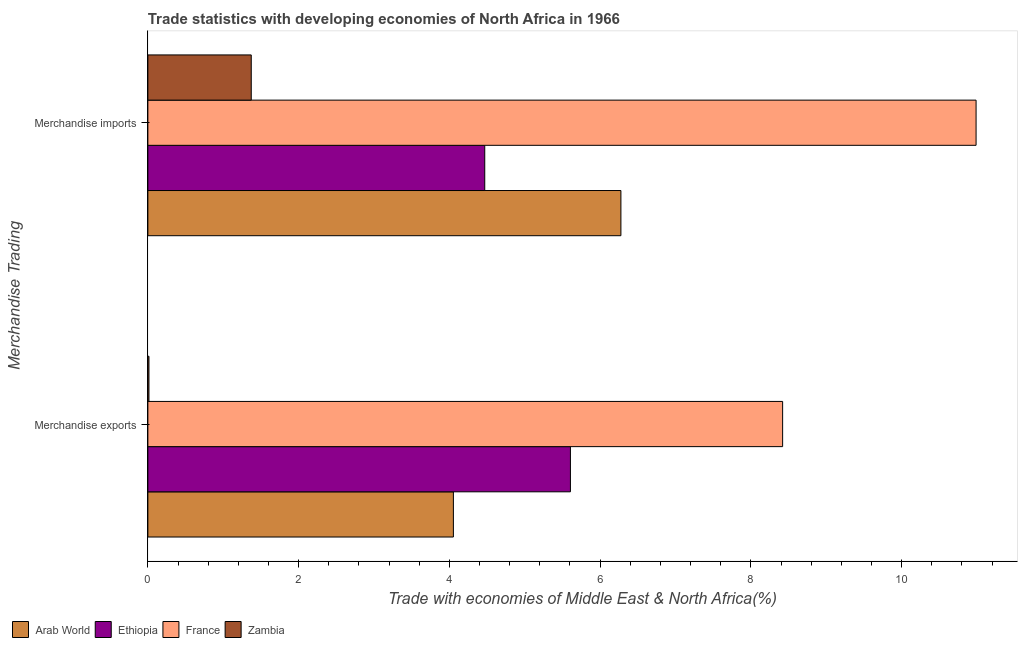How many different coloured bars are there?
Ensure brevity in your answer.  4. How many bars are there on the 2nd tick from the top?
Provide a short and direct response. 4. How many bars are there on the 1st tick from the bottom?
Ensure brevity in your answer.  4. What is the merchandise imports in Zambia?
Provide a succinct answer. 1.37. Across all countries, what is the maximum merchandise imports?
Your answer should be very brief. 10.99. Across all countries, what is the minimum merchandise exports?
Offer a terse response. 0.01. In which country was the merchandise exports minimum?
Ensure brevity in your answer.  Zambia. What is the total merchandise exports in the graph?
Ensure brevity in your answer.  18.09. What is the difference between the merchandise imports in Zambia and that in Arab World?
Offer a very short reply. -4.9. What is the difference between the merchandise imports in France and the merchandise exports in Arab World?
Your response must be concise. 6.93. What is the average merchandise imports per country?
Your answer should be very brief. 5.78. What is the difference between the merchandise exports and merchandise imports in Zambia?
Provide a short and direct response. -1.36. In how many countries, is the merchandise exports greater than 4.8 %?
Make the answer very short. 2. What is the ratio of the merchandise imports in Ethiopia to that in France?
Provide a succinct answer. 0.41. Is the merchandise imports in Arab World less than that in Zambia?
Give a very brief answer. No. In how many countries, is the merchandise imports greater than the average merchandise imports taken over all countries?
Provide a short and direct response. 2. What does the 4th bar from the top in Merchandise imports represents?
Your response must be concise. Arab World. What does the 4th bar from the bottom in Merchandise imports represents?
Keep it short and to the point. Zambia. How many bars are there?
Your answer should be very brief. 8. Are all the bars in the graph horizontal?
Offer a very short reply. Yes. How many countries are there in the graph?
Provide a short and direct response. 4. What is the difference between two consecutive major ticks on the X-axis?
Provide a short and direct response. 2. Are the values on the major ticks of X-axis written in scientific E-notation?
Make the answer very short. No. Does the graph contain any zero values?
Your answer should be very brief. No. Where does the legend appear in the graph?
Keep it short and to the point. Bottom left. How are the legend labels stacked?
Give a very brief answer. Horizontal. What is the title of the graph?
Your response must be concise. Trade statistics with developing economies of North Africa in 1966. What is the label or title of the X-axis?
Provide a succinct answer. Trade with economies of Middle East & North Africa(%). What is the label or title of the Y-axis?
Provide a succinct answer. Merchandise Trading. What is the Trade with economies of Middle East & North Africa(%) of Arab World in Merchandise exports?
Provide a short and direct response. 4.05. What is the Trade with economies of Middle East & North Africa(%) in Ethiopia in Merchandise exports?
Your response must be concise. 5.61. What is the Trade with economies of Middle East & North Africa(%) in France in Merchandise exports?
Ensure brevity in your answer.  8.42. What is the Trade with economies of Middle East & North Africa(%) in Zambia in Merchandise exports?
Keep it short and to the point. 0.01. What is the Trade with economies of Middle East & North Africa(%) in Arab World in Merchandise imports?
Your response must be concise. 6.28. What is the Trade with economies of Middle East & North Africa(%) of Ethiopia in Merchandise imports?
Offer a terse response. 4.47. What is the Trade with economies of Middle East & North Africa(%) of France in Merchandise imports?
Offer a very short reply. 10.99. What is the Trade with economies of Middle East & North Africa(%) in Zambia in Merchandise imports?
Keep it short and to the point. 1.37. Across all Merchandise Trading, what is the maximum Trade with economies of Middle East & North Africa(%) of Arab World?
Provide a succinct answer. 6.28. Across all Merchandise Trading, what is the maximum Trade with economies of Middle East & North Africa(%) of Ethiopia?
Make the answer very short. 5.61. Across all Merchandise Trading, what is the maximum Trade with economies of Middle East & North Africa(%) in France?
Your answer should be very brief. 10.99. Across all Merchandise Trading, what is the maximum Trade with economies of Middle East & North Africa(%) in Zambia?
Provide a succinct answer. 1.37. Across all Merchandise Trading, what is the minimum Trade with economies of Middle East & North Africa(%) of Arab World?
Offer a terse response. 4.05. Across all Merchandise Trading, what is the minimum Trade with economies of Middle East & North Africa(%) of Ethiopia?
Offer a terse response. 4.47. Across all Merchandise Trading, what is the minimum Trade with economies of Middle East & North Africa(%) of France?
Provide a short and direct response. 8.42. Across all Merchandise Trading, what is the minimum Trade with economies of Middle East & North Africa(%) of Zambia?
Provide a succinct answer. 0.01. What is the total Trade with economies of Middle East & North Africa(%) of Arab World in the graph?
Ensure brevity in your answer.  10.33. What is the total Trade with economies of Middle East & North Africa(%) of Ethiopia in the graph?
Make the answer very short. 10.08. What is the total Trade with economies of Middle East & North Africa(%) in France in the graph?
Give a very brief answer. 19.41. What is the total Trade with economies of Middle East & North Africa(%) in Zambia in the graph?
Provide a succinct answer. 1.39. What is the difference between the Trade with economies of Middle East & North Africa(%) in Arab World in Merchandise exports and that in Merchandise imports?
Your response must be concise. -2.22. What is the difference between the Trade with economies of Middle East & North Africa(%) in Ethiopia in Merchandise exports and that in Merchandise imports?
Your response must be concise. 1.14. What is the difference between the Trade with economies of Middle East & North Africa(%) in France in Merchandise exports and that in Merchandise imports?
Your answer should be compact. -2.57. What is the difference between the Trade with economies of Middle East & North Africa(%) of Zambia in Merchandise exports and that in Merchandise imports?
Ensure brevity in your answer.  -1.36. What is the difference between the Trade with economies of Middle East & North Africa(%) in Arab World in Merchandise exports and the Trade with economies of Middle East & North Africa(%) in Ethiopia in Merchandise imports?
Ensure brevity in your answer.  -0.42. What is the difference between the Trade with economies of Middle East & North Africa(%) of Arab World in Merchandise exports and the Trade with economies of Middle East & North Africa(%) of France in Merchandise imports?
Give a very brief answer. -6.93. What is the difference between the Trade with economies of Middle East & North Africa(%) of Arab World in Merchandise exports and the Trade with economies of Middle East & North Africa(%) of Zambia in Merchandise imports?
Your response must be concise. 2.68. What is the difference between the Trade with economies of Middle East & North Africa(%) in Ethiopia in Merchandise exports and the Trade with economies of Middle East & North Africa(%) in France in Merchandise imports?
Your response must be concise. -5.38. What is the difference between the Trade with economies of Middle East & North Africa(%) in Ethiopia in Merchandise exports and the Trade with economies of Middle East & North Africa(%) in Zambia in Merchandise imports?
Your response must be concise. 4.23. What is the difference between the Trade with economies of Middle East & North Africa(%) of France in Merchandise exports and the Trade with economies of Middle East & North Africa(%) of Zambia in Merchandise imports?
Provide a short and direct response. 7.05. What is the average Trade with economies of Middle East & North Africa(%) in Arab World per Merchandise Trading?
Provide a succinct answer. 5.16. What is the average Trade with economies of Middle East & North Africa(%) in Ethiopia per Merchandise Trading?
Offer a terse response. 5.04. What is the average Trade with economies of Middle East & North Africa(%) of France per Merchandise Trading?
Provide a succinct answer. 9.7. What is the average Trade with economies of Middle East & North Africa(%) of Zambia per Merchandise Trading?
Keep it short and to the point. 0.69. What is the difference between the Trade with economies of Middle East & North Africa(%) of Arab World and Trade with economies of Middle East & North Africa(%) of Ethiopia in Merchandise exports?
Offer a terse response. -1.55. What is the difference between the Trade with economies of Middle East & North Africa(%) of Arab World and Trade with economies of Middle East & North Africa(%) of France in Merchandise exports?
Make the answer very short. -4.37. What is the difference between the Trade with economies of Middle East & North Africa(%) of Arab World and Trade with economies of Middle East & North Africa(%) of Zambia in Merchandise exports?
Give a very brief answer. 4.04. What is the difference between the Trade with economies of Middle East & North Africa(%) in Ethiopia and Trade with economies of Middle East & North Africa(%) in France in Merchandise exports?
Give a very brief answer. -2.82. What is the difference between the Trade with economies of Middle East & North Africa(%) in Ethiopia and Trade with economies of Middle East & North Africa(%) in Zambia in Merchandise exports?
Keep it short and to the point. 5.59. What is the difference between the Trade with economies of Middle East & North Africa(%) of France and Trade with economies of Middle East & North Africa(%) of Zambia in Merchandise exports?
Offer a terse response. 8.41. What is the difference between the Trade with economies of Middle East & North Africa(%) of Arab World and Trade with economies of Middle East & North Africa(%) of Ethiopia in Merchandise imports?
Keep it short and to the point. 1.81. What is the difference between the Trade with economies of Middle East & North Africa(%) in Arab World and Trade with economies of Middle East & North Africa(%) in France in Merchandise imports?
Give a very brief answer. -4.71. What is the difference between the Trade with economies of Middle East & North Africa(%) in Arab World and Trade with economies of Middle East & North Africa(%) in Zambia in Merchandise imports?
Give a very brief answer. 4.9. What is the difference between the Trade with economies of Middle East & North Africa(%) in Ethiopia and Trade with economies of Middle East & North Africa(%) in France in Merchandise imports?
Provide a short and direct response. -6.52. What is the difference between the Trade with economies of Middle East & North Africa(%) of Ethiopia and Trade with economies of Middle East & North Africa(%) of Zambia in Merchandise imports?
Offer a terse response. 3.1. What is the difference between the Trade with economies of Middle East & North Africa(%) in France and Trade with economies of Middle East & North Africa(%) in Zambia in Merchandise imports?
Keep it short and to the point. 9.62. What is the ratio of the Trade with economies of Middle East & North Africa(%) in Arab World in Merchandise exports to that in Merchandise imports?
Make the answer very short. 0.65. What is the ratio of the Trade with economies of Middle East & North Africa(%) in Ethiopia in Merchandise exports to that in Merchandise imports?
Provide a succinct answer. 1.25. What is the ratio of the Trade with economies of Middle East & North Africa(%) of France in Merchandise exports to that in Merchandise imports?
Your response must be concise. 0.77. What is the ratio of the Trade with economies of Middle East & North Africa(%) of Zambia in Merchandise exports to that in Merchandise imports?
Your response must be concise. 0.01. What is the difference between the highest and the second highest Trade with economies of Middle East & North Africa(%) in Arab World?
Keep it short and to the point. 2.22. What is the difference between the highest and the second highest Trade with economies of Middle East & North Africa(%) of Ethiopia?
Provide a succinct answer. 1.14. What is the difference between the highest and the second highest Trade with economies of Middle East & North Africa(%) in France?
Your answer should be compact. 2.57. What is the difference between the highest and the second highest Trade with economies of Middle East & North Africa(%) of Zambia?
Your answer should be compact. 1.36. What is the difference between the highest and the lowest Trade with economies of Middle East & North Africa(%) of Arab World?
Make the answer very short. 2.22. What is the difference between the highest and the lowest Trade with economies of Middle East & North Africa(%) of Ethiopia?
Provide a short and direct response. 1.14. What is the difference between the highest and the lowest Trade with economies of Middle East & North Africa(%) of France?
Make the answer very short. 2.57. What is the difference between the highest and the lowest Trade with economies of Middle East & North Africa(%) of Zambia?
Provide a succinct answer. 1.36. 